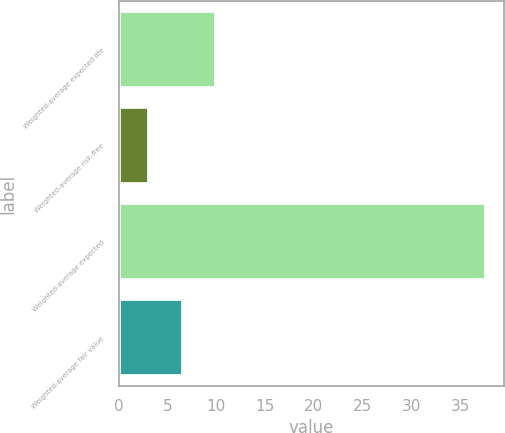Convert chart. <chart><loc_0><loc_0><loc_500><loc_500><bar_chart><fcel>Weighted-average expected life<fcel>Weighted-average risk-free<fcel>Weighted-average expected<fcel>Weighted-average fair value<nl><fcel>10<fcel>3.1<fcel>37.6<fcel>6.55<nl></chart> 